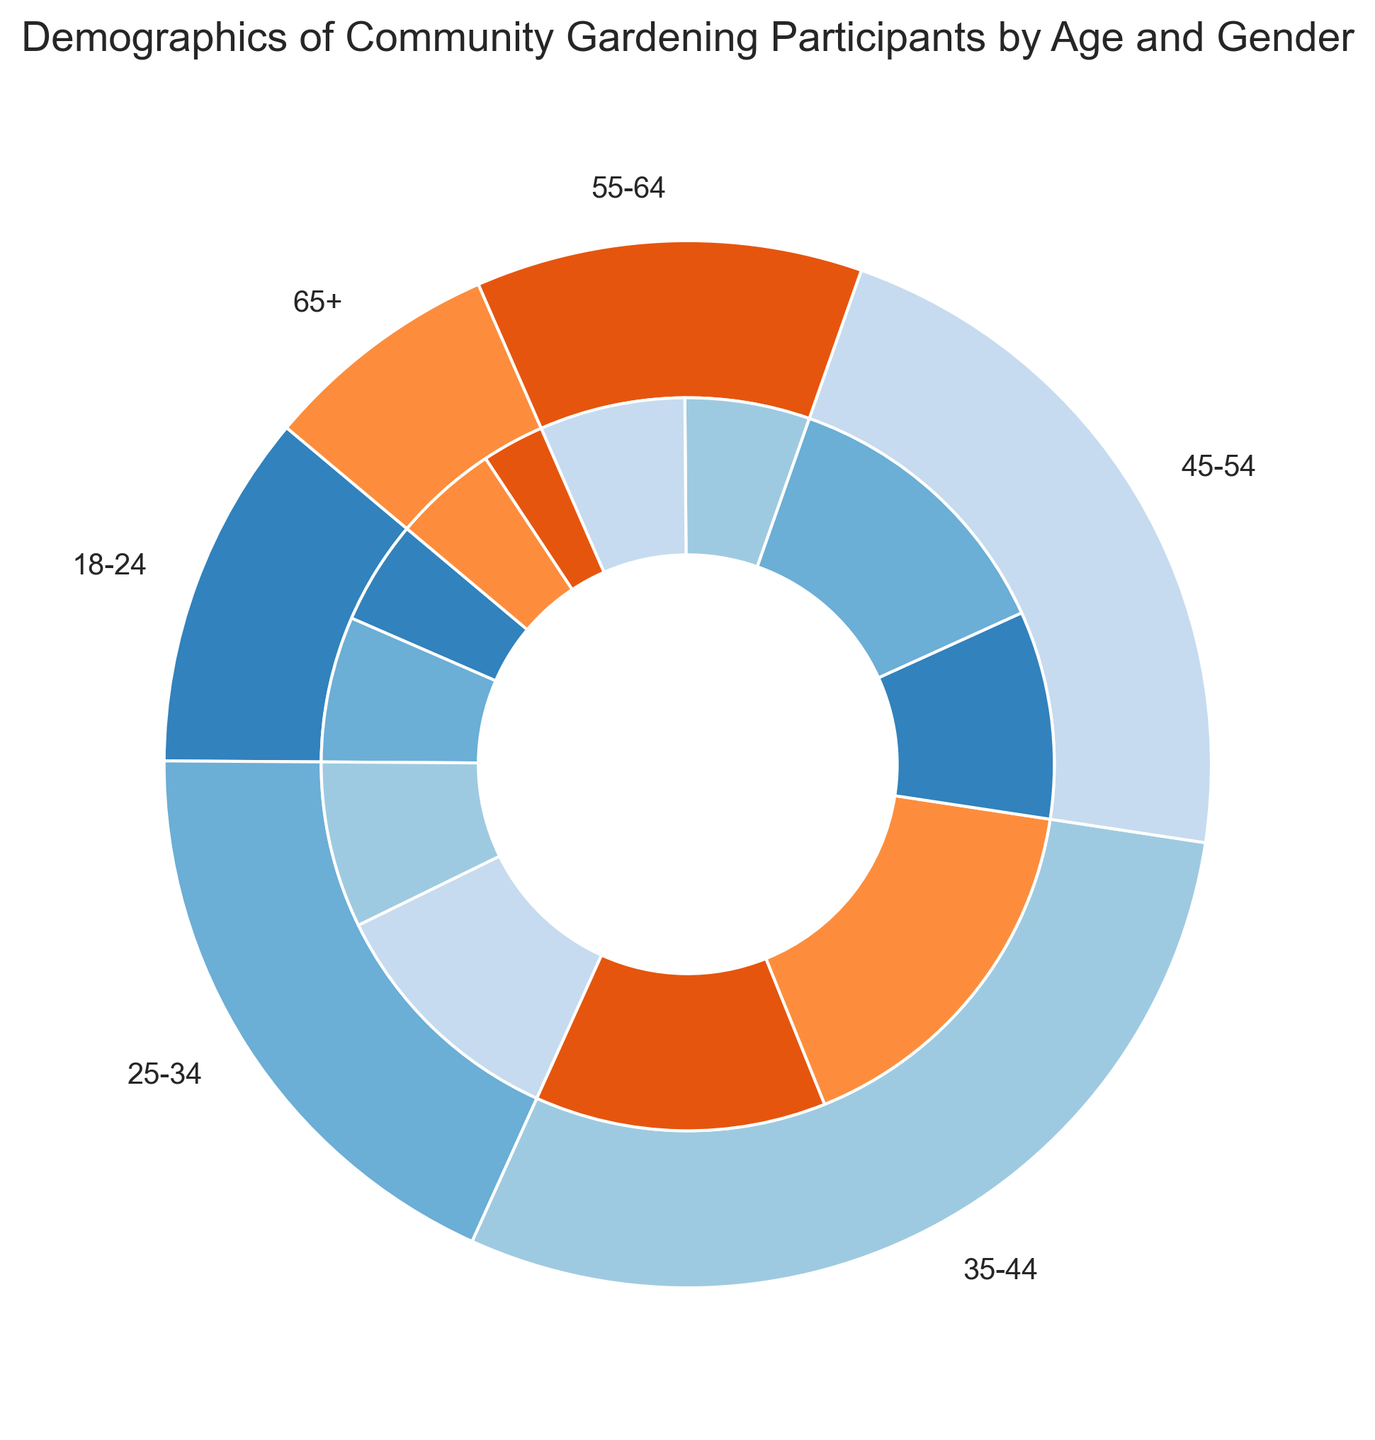Which age group has the highest number of female participants? Look at the inner ring of the nested pie chart for each age group segment and identify the segments representing females. Compare their sizes visually to see which is the largest.
Answer: 35-44 How many participants are in the 25-34 age group? Refer to the outer ring of the pie chart where the 25-34 age group is labeled. The total count for this age group is the sum of its male and female participants.
Answer: 20 Which gender has more participants in the 45-54 age group? Look at the inner ring within the 45-54 age group segment and compare the sizes of the male and female sections visually.
Answer: Female What is the total number of participants in the 55-64 and 65+ age groups combined? Sum the total participants of the 55-64 age group (6 + 7) and the 65+ age group (3 + 5).
Answer: 21 Are there more male or female participants overall? Add up the male participants across all age groups and the female participants across all age groups, then compare the two totals.
Answer: Female Which age group has the smallest number of male participants? Refer to the inner ring for each age group and identify the smallest male segment.
Answer: 65+ What age group has the largest difference between male and female participants? Calculate the difference between male and female participants for each age group and find the largest difference. Examining visually: 18-24 (2), 25-34 (4), 35-44 (4), 45-54 (4), 55-64 (1), 65+ (2).
Answer: 25-34, 35-44, 45-54 (all have a difference of 4) What percentage of the total participants are in the 35-44 age group? Sum the total number of participants across all age groups. Then, divide the 35-44 age group's total (14 + 18) by the overall total and multiply by 100. (14 + 18) / (5 + 7 + 8 + 12 + 14 + 18 + 10 + 14 + 6 + 7 + 3 + 5) * 100 = 32 / 109 * 100 ≈ 29.36%
Answer: ≈ 29.36% Which age group has a more balanced gender distribution? Compare the sizes of the inner segments (male and female) within each age group in the nested pie chart. The age group where male and female segments are nearly equal will have a more balanced gender distribution.
Answer: 55-64 How many more males are there in the 35-44 age group compared to the 18-24 age group? Subtract the number of male participants in the 18-24 age group from those in the 35-44 age group (14 - 5).
Answer: 9 